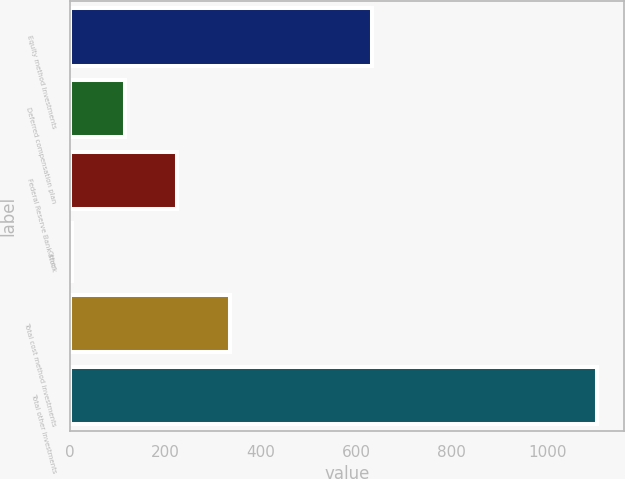Convert chart. <chart><loc_0><loc_0><loc_500><loc_500><bar_chart><fcel>Equity method Investments<fcel>Deferred compensation plan<fcel>Federal Reserve Bank stock<fcel>Other<fcel>Total cost method investments<fcel>Total other investments<nl><fcel>633<fcel>114.1<fcel>224.2<fcel>4<fcel>334.3<fcel>1105<nl></chart> 